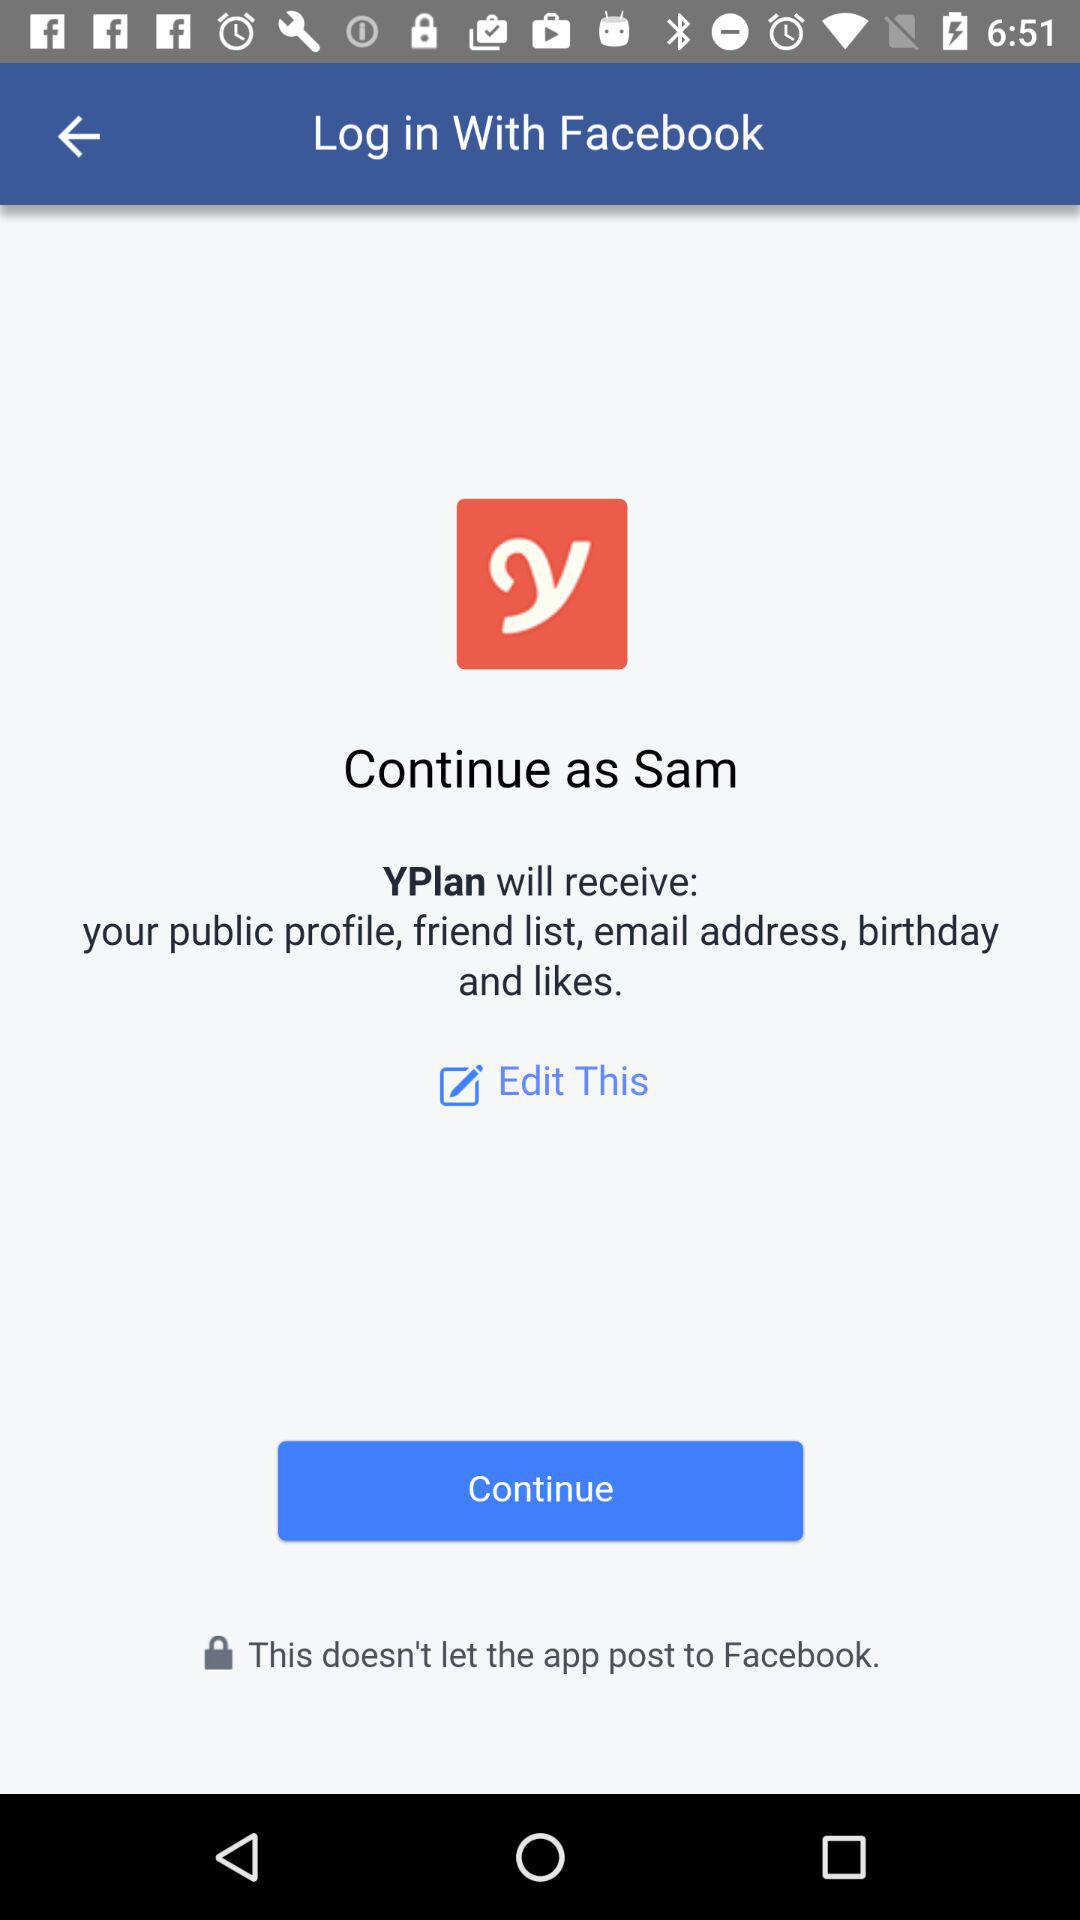How can we log in? You can log in with "Facebook". 